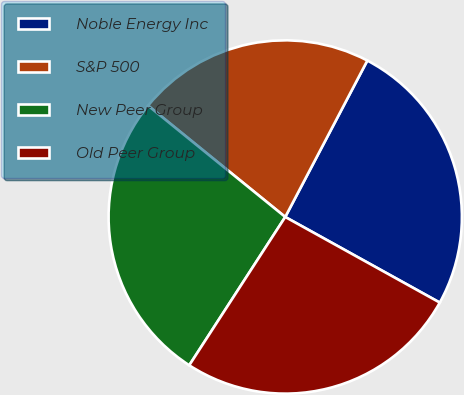Convert chart to OTSL. <chart><loc_0><loc_0><loc_500><loc_500><pie_chart><fcel>Noble Energy Inc<fcel>S&P 500<fcel>New Peer Group<fcel>Old Peer Group<nl><fcel>25.36%<fcel>21.84%<fcel>26.71%<fcel>26.09%<nl></chart> 